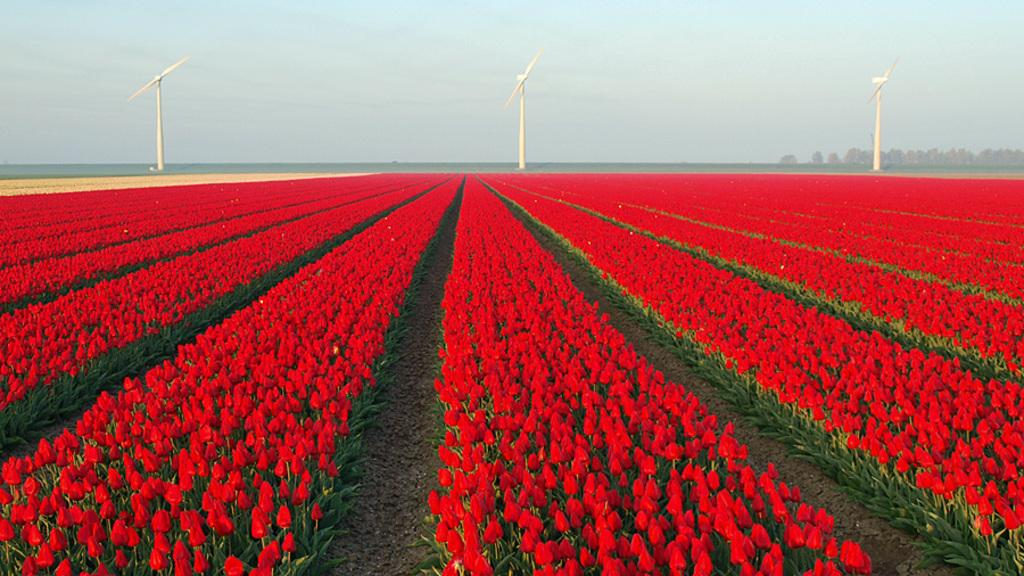What type of landscape is depicted in the image? There is a flower garden in the image. What structures can be seen in the flower garden? There are windmills in the image. What type of vegetation is present in the image? There are many trees in the image. How many socks are hanging from the trees in the image? There are no socks present in the image; it features a flower garden with windmills and trees. What type of scarf can be seen wrapped around the windmills in the image? There is no scarf present in the image; it only features windmills, trees, and a flower garden. 